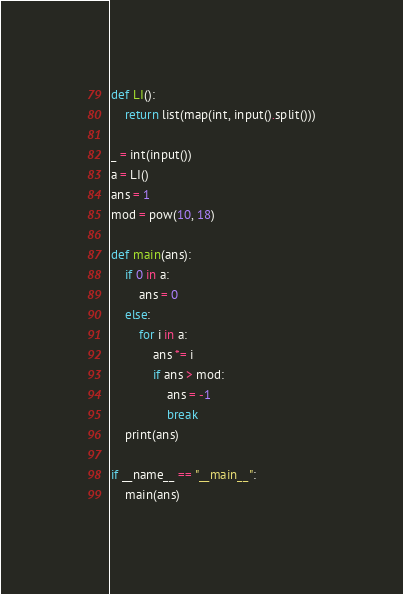Convert code to text. <code><loc_0><loc_0><loc_500><loc_500><_Python_>def LI():
    return list(map(int, input().split()))

_ = int(input())
a = LI()
ans = 1
mod = pow(10, 18)

def main(ans):
    if 0 in a:
        ans = 0
    else:
        for i in a:
            ans *= i
            if ans > mod:
                ans = -1
                break
    print(ans)

if __name__ == "__main__":
    main(ans)</code> 